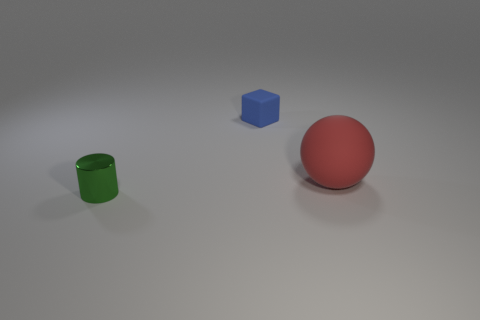Subtract all cyan blocks. Subtract all green cylinders. How many blocks are left? 1 Add 2 small matte objects. How many objects exist? 5 Subtract all blocks. How many objects are left? 2 Subtract 0 yellow balls. How many objects are left? 3 Subtract all cubes. Subtract all tiny matte objects. How many objects are left? 1 Add 1 big red balls. How many big red balls are left? 2 Add 3 cylinders. How many cylinders exist? 4 